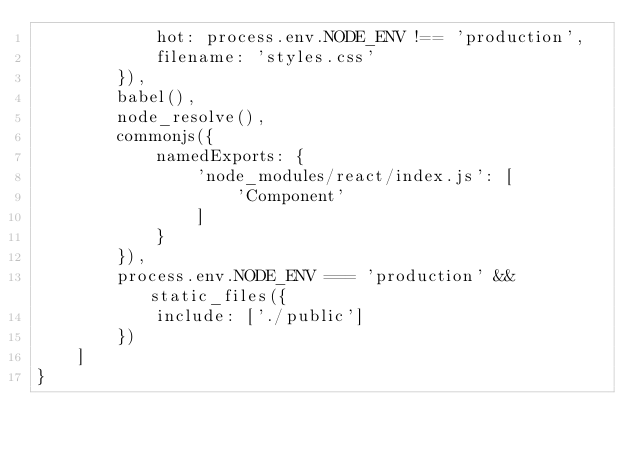<code> <loc_0><loc_0><loc_500><loc_500><_JavaScript_>            hot: process.env.NODE_ENV !== 'production',
            filename: 'styles.css'
        }),
        babel(),
        node_resolve(),
        commonjs({
            namedExports: {
                'node_modules/react/index.js': [
                    'Component'
                ]
            }
        }),
        process.env.NODE_ENV === 'production' && static_files({
            include: ['./public']
        })
    ]
}</code> 